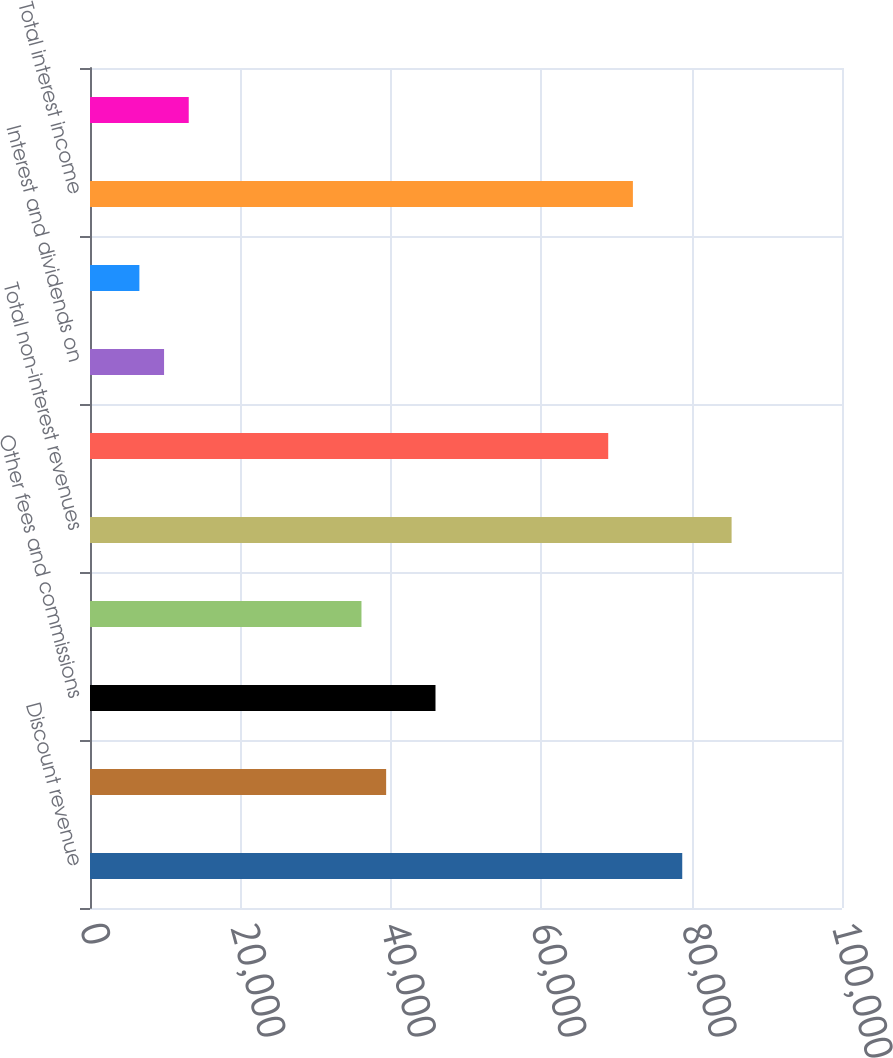<chart> <loc_0><loc_0><loc_500><loc_500><bar_chart><fcel>Discount revenue<fcel>Net card fees<fcel>Other fees and commissions<fcel>Other<fcel>Total non-interest revenues<fcel>Interest on loans<fcel>Interest and dividends on<fcel>Deposits with banks and other<fcel>Total interest income<fcel>Deposits<nl><fcel>78756.1<fcel>39380.6<fcel>45943.2<fcel>36099.3<fcel>85318.7<fcel>68912.2<fcel>9848.94<fcel>6567.65<fcel>72193.5<fcel>13130.2<nl></chart> 